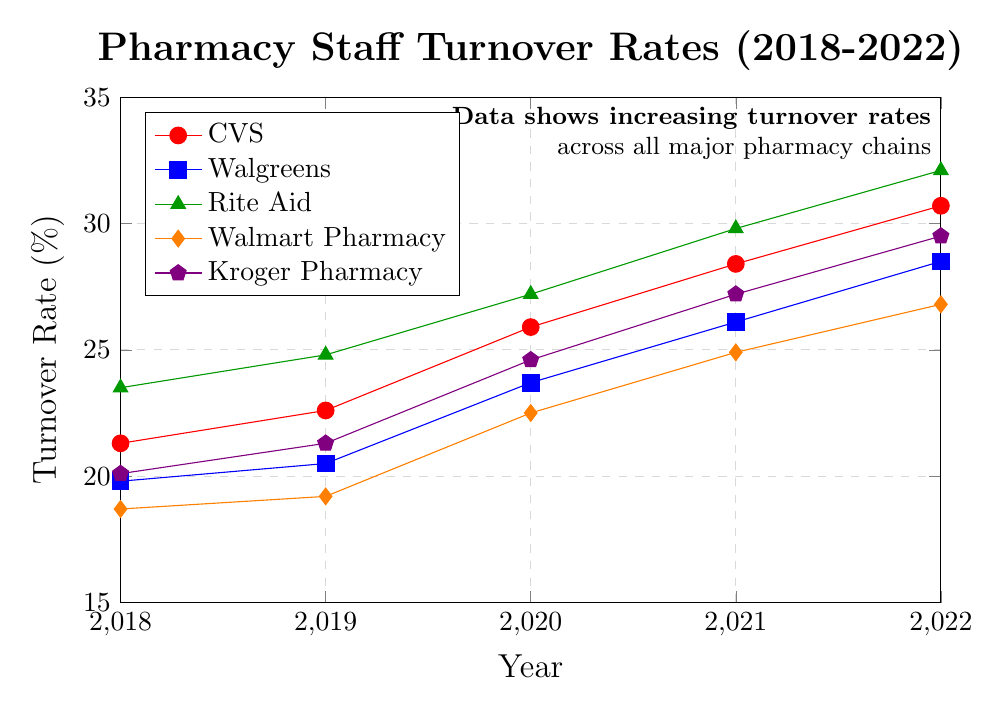what is the trend in turnover rates for CVS from 2018 to 2022? The turnover rates for CVS start at 21.3% in 2018 and increase each year, reaching 30.7% in 2022. This indicates a consistent upward trend in turnover rates for CVS over the period.
Answer: Increasing which pharmacy chain had the lowest turnover rate in 2020? To find the lowest turnover rate in 2020, we compare the turnover rates of all chains for that year: CVS (25.9%), Walgreens (23.7%), Rite Aid (27.2%), Walmart Pharmacy (22.5%), and Kroger Pharmacy (24.6%). Walmart Pharmacy has the lowest rate at 22.5%.
Answer: Walmart Pharmacy how much did the turnover rate for Rite Aid increase from 2018 to 2022? The turnover rate for Rite Aid in 2018 was 23.5%, and it increased to 32.1% in 2022. The difference is 32.1% - 23.5% = 8.6%.
Answer: 8.6% which pharmacy chain experienced the greatest increase in turnover rates from 2018 to 2022? To determine the chain with the greatest increase, we calculate the differences for each chain:
- CVS: 30.7% - 21.3% = 9.4%
- Walgreens: 28.5% - 19.8% = 8.7%
- Rite Aid: 32.1% - 23.5% = 8.6%
- Walmart Pharmacy: 26.8% - 18.7% = 8.1%
- Kroger Pharmacy: 29.5% - 20.1% = 9.4%
CVS and Kroger Pharmacy both had the highest increase of 9.4%.
Answer: CVS and Kroger Pharmacy which year saw the largest average turnover rate among the pharmacy chains? Calculate the average turnover rate for each year across all chains:
- 2018: (21.3 + 19.8 + 23.5 + 18.7 + 20.1) / 5 = 20.68%
- 2019: (22.6 + 20.5 + 24.8 + 19.2 + 21.3) / 5 = 21.68%
- 2020: (25.9 + 23.7 + 27.2 + 22.5 + 24.6) / 5 = 24.78%
- 2021: (28.4 + 26.1 + 29.8 + 24.9 + 27.2) / 5 = 27.28%
- 2022: (30.7 + 28.5 + 32.1 + 26.8 + 29.5) / 5 = 29.52%
2022 saw the highest average turnover rate among all the years.
Answer: 2022 how did Walgreens' turnover rate change between 2019 and 2021? The turnover rate for Walgreens in 2019 was 20.5%, and it increased to 26.1% by 2021. The difference is 26.1% - 20.5% = 5.6%.
Answer: Increased by 5.6% which pharmacy chains had turnover rates greater than 25% in 2021? Check each chain's turnover rate in 2021:
- CVS: 28.4%
- Walgreens: 26.1%
- Rite Aid: 29.8%
- Walmart Pharmacy: 24.9%
- Kroger Pharmacy: 27.2%
CVS, Walgreens, Rite Aid, and Kroger Pharmacy each had rates greater than 25% in 2021.
Answer: CVS, Walgreens, Rite Aid, Kroger Pharmacy 